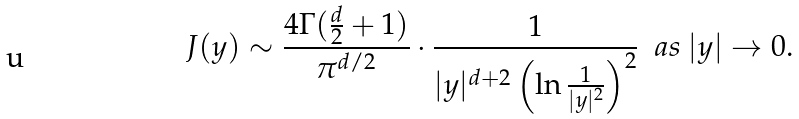Convert formula to latex. <formula><loc_0><loc_0><loc_500><loc_500>J ( y ) \sim \frac { 4 \Gamma ( \frac { d } { 2 } + 1 ) } { \pi ^ { d / 2 } } \cdot \frac { 1 } { | y | ^ { d + 2 } \left ( \ln \frac { 1 } { | y | ^ { 2 } } \right ) ^ { 2 } } \ \ a s \ | y | \to 0 .</formula> 